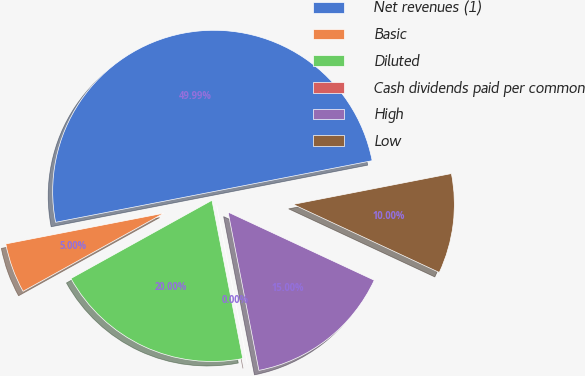Convert chart to OTSL. <chart><loc_0><loc_0><loc_500><loc_500><pie_chart><fcel>Net revenues (1)<fcel>Basic<fcel>Diluted<fcel>Cash dividends paid per common<fcel>High<fcel>Low<nl><fcel>49.99%<fcel>5.0%<fcel>20.0%<fcel>0.0%<fcel>15.0%<fcel>10.0%<nl></chart> 